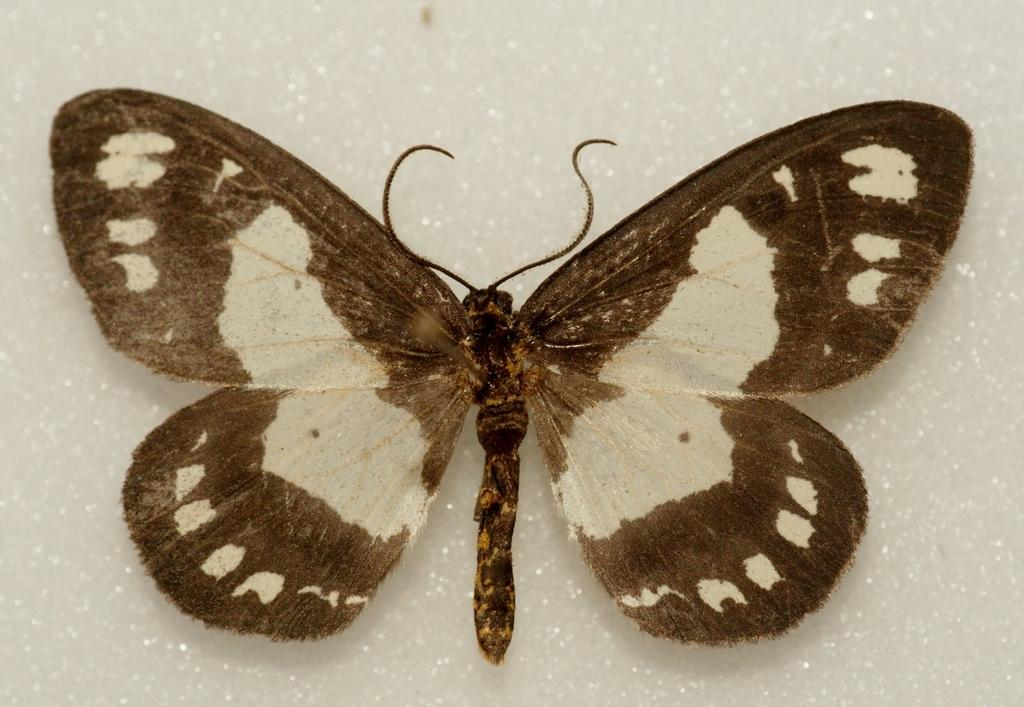What is there is a butterfly in the image, what is its location in relation to the image? The butterfly is in the foreground of the image. What is the color of the surface where the butterfly is resting? The butterfly is on a white surface. Can you see any goldfish swimming in the image? There are no goldfish present in the image; it features a butterfly on a white surface. 